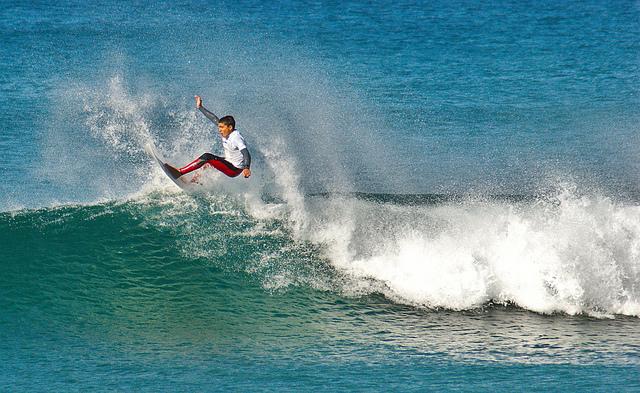Is the surfer wearing a white shirt?
Short answer required. Yes. What water sport is the person participating in?
Be succinct. Surfing. Is the wave foamy?
Keep it brief. Yes. Is the wave big?
Give a very brief answer. Yes. 